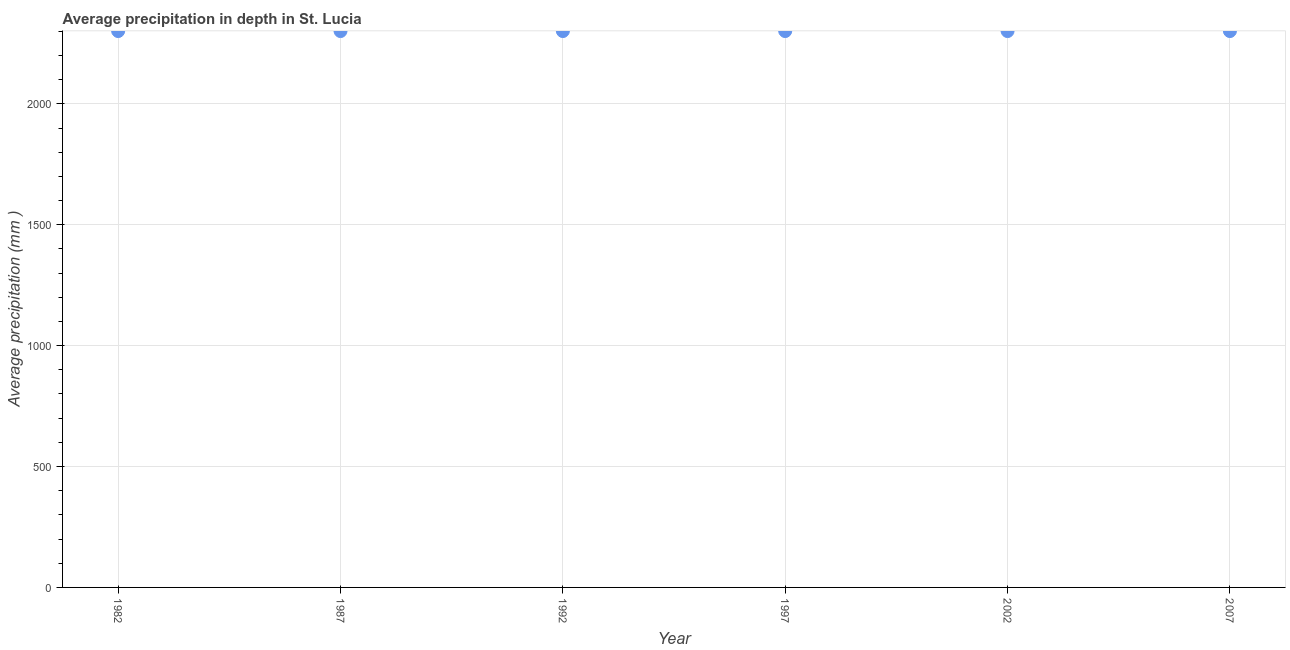What is the average precipitation in depth in 1987?
Ensure brevity in your answer.  2301. Across all years, what is the maximum average precipitation in depth?
Your answer should be compact. 2301. Across all years, what is the minimum average precipitation in depth?
Your answer should be very brief. 2301. In which year was the average precipitation in depth maximum?
Offer a terse response. 1982. In which year was the average precipitation in depth minimum?
Offer a very short reply. 1982. What is the sum of the average precipitation in depth?
Offer a terse response. 1.38e+04. What is the difference between the average precipitation in depth in 1982 and 2002?
Give a very brief answer. 0. What is the average average precipitation in depth per year?
Provide a short and direct response. 2301. What is the median average precipitation in depth?
Your response must be concise. 2301. Do a majority of the years between 1997 and 2002 (inclusive) have average precipitation in depth greater than 1500 mm?
Offer a very short reply. Yes. What is the ratio of the average precipitation in depth in 1987 to that in 2002?
Provide a short and direct response. 1. Is the difference between the average precipitation in depth in 1992 and 2002 greater than the difference between any two years?
Your response must be concise. Yes. What is the difference between the highest and the second highest average precipitation in depth?
Give a very brief answer. 0. Is the sum of the average precipitation in depth in 1987 and 1992 greater than the maximum average precipitation in depth across all years?
Your response must be concise. Yes. Does the average precipitation in depth monotonically increase over the years?
Make the answer very short. No. How many dotlines are there?
Provide a short and direct response. 1. How many years are there in the graph?
Your response must be concise. 6. What is the title of the graph?
Your answer should be compact. Average precipitation in depth in St. Lucia. What is the label or title of the X-axis?
Your response must be concise. Year. What is the label or title of the Y-axis?
Make the answer very short. Average precipitation (mm ). What is the Average precipitation (mm ) in 1982?
Your answer should be compact. 2301. What is the Average precipitation (mm ) in 1987?
Your answer should be very brief. 2301. What is the Average precipitation (mm ) in 1992?
Your answer should be very brief. 2301. What is the Average precipitation (mm ) in 1997?
Offer a very short reply. 2301. What is the Average precipitation (mm ) in 2002?
Provide a succinct answer. 2301. What is the Average precipitation (mm ) in 2007?
Keep it short and to the point. 2301. What is the difference between the Average precipitation (mm ) in 1982 and 1992?
Your response must be concise. 0. What is the difference between the Average precipitation (mm ) in 1987 and 2002?
Give a very brief answer. 0. What is the difference between the Average precipitation (mm ) in 1997 and 2007?
Your answer should be very brief. 0. What is the ratio of the Average precipitation (mm ) in 1982 to that in 1987?
Make the answer very short. 1. What is the ratio of the Average precipitation (mm ) in 1982 to that in 1992?
Provide a short and direct response. 1. What is the ratio of the Average precipitation (mm ) in 1982 to that in 2002?
Your answer should be compact. 1. What is the ratio of the Average precipitation (mm ) in 1982 to that in 2007?
Offer a very short reply. 1. What is the ratio of the Average precipitation (mm ) in 1992 to that in 2002?
Give a very brief answer. 1. What is the ratio of the Average precipitation (mm ) in 1997 to that in 2002?
Your response must be concise. 1. What is the ratio of the Average precipitation (mm ) in 1997 to that in 2007?
Make the answer very short. 1. 